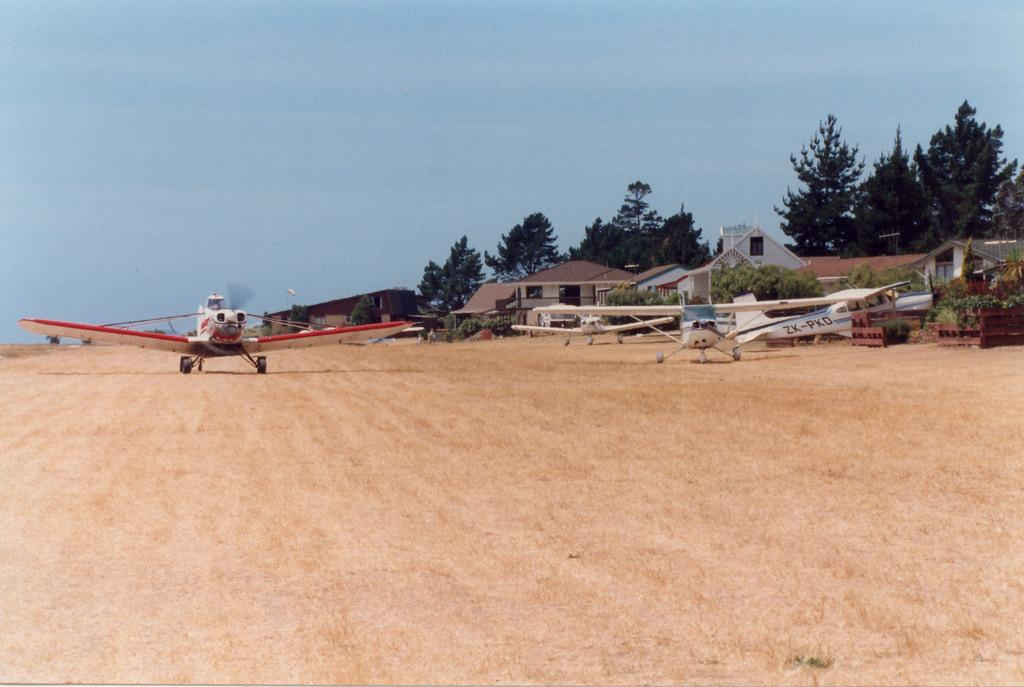What type of vehicles can be seen in the image? There are helicopters in the image. What type of structures are visible in the image? There are houses in the image. What type of vegetation can be seen in the image? There are plants and trees in the image. What is visible in the background of the image? The sky is visible in the background of the image. What type of button can be seen on the helicopter in the image? There is no button visible on the helicopters in the image. What type of ring can be seen on the trees in the image? There is no ring visible on the trees in the image. 